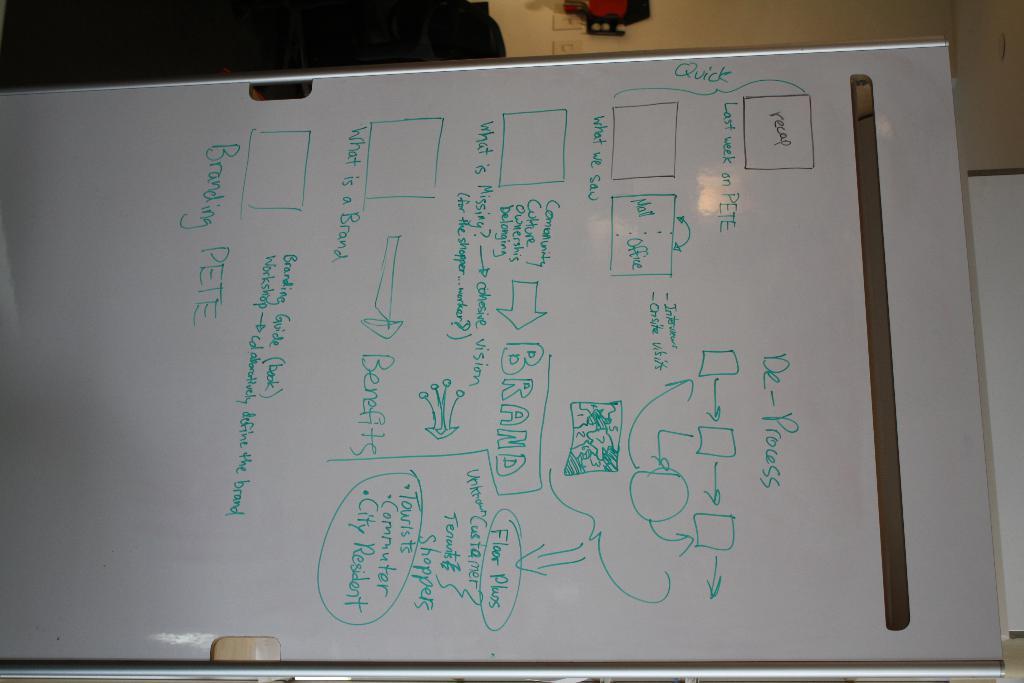Could you give a brief overview of what you see in this image? This looks like a whiteboard. I can see the letters and the diagrams on it. In the background, that looks like a wall. 